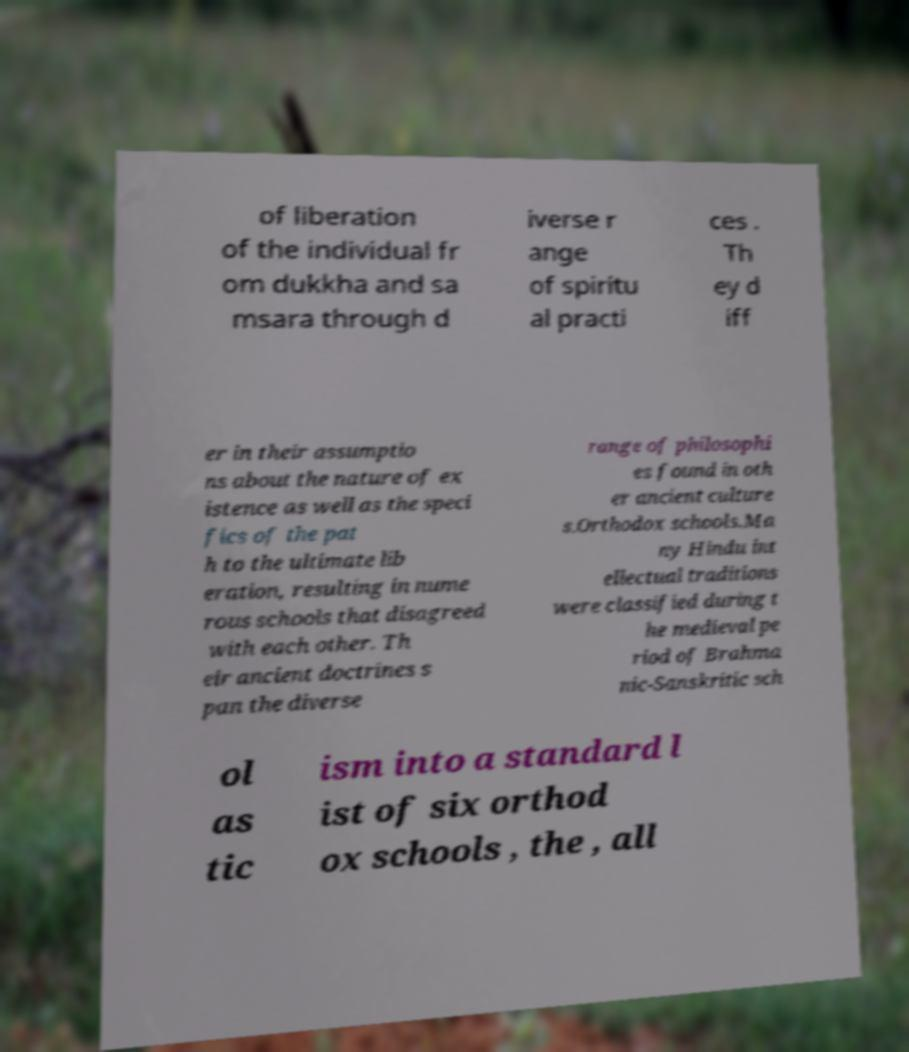Please identify and transcribe the text found in this image. of liberation of the individual fr om dukkha and sa msara through d iverse r ange of spiritu al practi ces . Th ey d iff er in their assumptio ns about the nature of ex istence as well as the speci fics of the pat h to the ultimate lib eration, resulting in nume rous schools that disagreed with each other. Th eir ancient doctrines s pan the diverse range of philosophi es found in oth er ancient culture s.Orthodox schools.Ma ny Hindu int ellectual traditions were classified during t he medieval pe riod of Brahma nic-Sanskritic sch ol as tic ism into a standard l ist of six orthod ox schools , the , all 